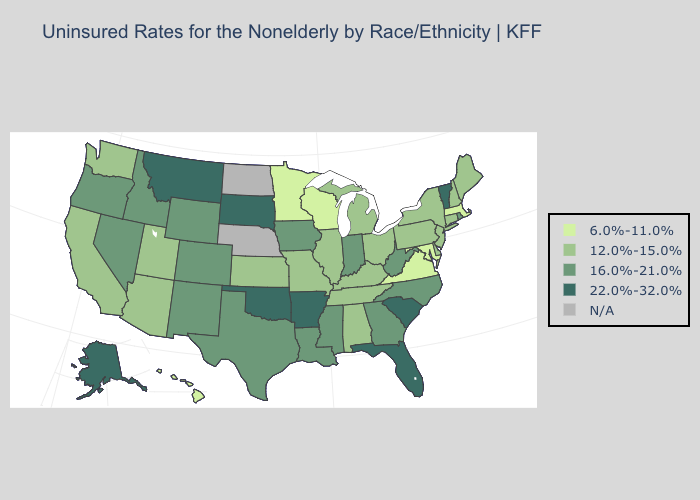What is the highest value in the USA?
Write a very short answer. 22.0%-32.0%. Name the states that have a value in the range 6.0%-11.0%?
Be succinct. Hawaii, Maryland, Massachusetts, Minnesota, Virginia, Wisconsin. Does Delaware have the lowest value in the South?
Concise answer only. No. What is the value of Hawaii?
Be succinct. 6.0%-11.0%. Does New Jersey have the highest value in the Northeast?
Short answer required. No. What is the highest value in the USA?
Quick response, please. 22.0%-32.0%. What is the value of Alabama?
Quick response, please. 12.0%-15.0%. What is the value of Maine?
Short answer required. 12.0%-15.0%. Name the states that have a value in the range 12.0%-15.0%?
Short answer required. Alabama, Arizona, California, Connecticut, Delaware, Illinois, Kansas, Kentucky, Maine, Michigan, Missouri, New Hampshire, New Jersey, New York, Ohio, Pennsylvania, Tennessee, Utah, Washington. What is the highest value in states that border Connecticut?
Keep it brief. 16.0%-21.0%. Name the states that have a value in the range 12.0%-15.0%?
Quick response, please. Alabama, Arizona, California, Connecticut, Delaware, Illinois, Kansas, Kentucky, Maine, Michigan, Missouri, New Hampshire, New Jersey, New York, Ohio, Pennsylvania, Tennessee, Utah, Washington. Among the states that border Massachusetts , does New Hampshire have the lowest value?
Be succinct. Yes. Does the map have missing data?
Concise answer only. Yes. What is the lowest value in the MidWest?
Write a very short answer. 6.0%-11.0%. 